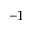Convert formula to latex. <formula><loc_0><loc_0><loc_500><loc_500>^ { - 1 }</formula> 